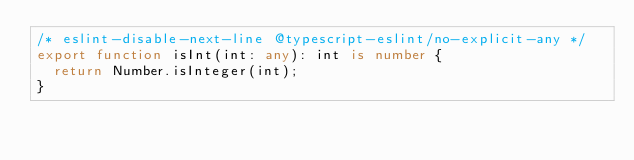Convert code to text. <code><loc_0><loc_0><loc_500><loc_500><_TypeScript_>/* eslint-disable-next-line @typescript-eslint/no-explicit-any */
export function isInt(int: any): int is number {
  return Number.isInteger(int);
}
</code> 